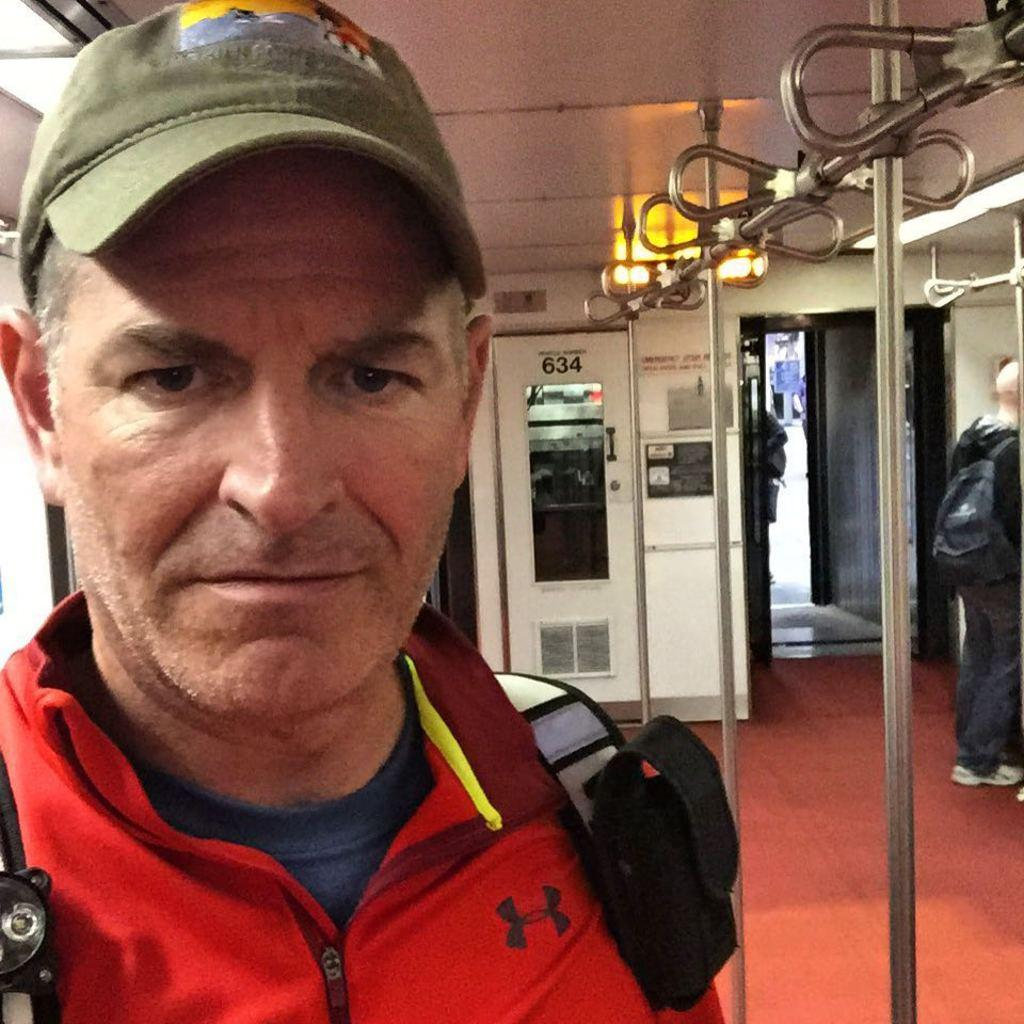Who is the main subject in the image? There is a person in the center of the image. What is the person wearing on their back? The person is wearing a backpack. What is the person wearing on their head? The person is wearing a cap. Can you describe the other person in the image? There is another person in the background of the image. What type of kitten is the person holding in the image? There is no kitten present in the image. What is the name of the competition the person is participating in? There is no competition mentioned or depicted in the image. In which direction is the person facing in the image, relative to the north? The image does not provide enough information to determine the person's orientation relative to the north. 